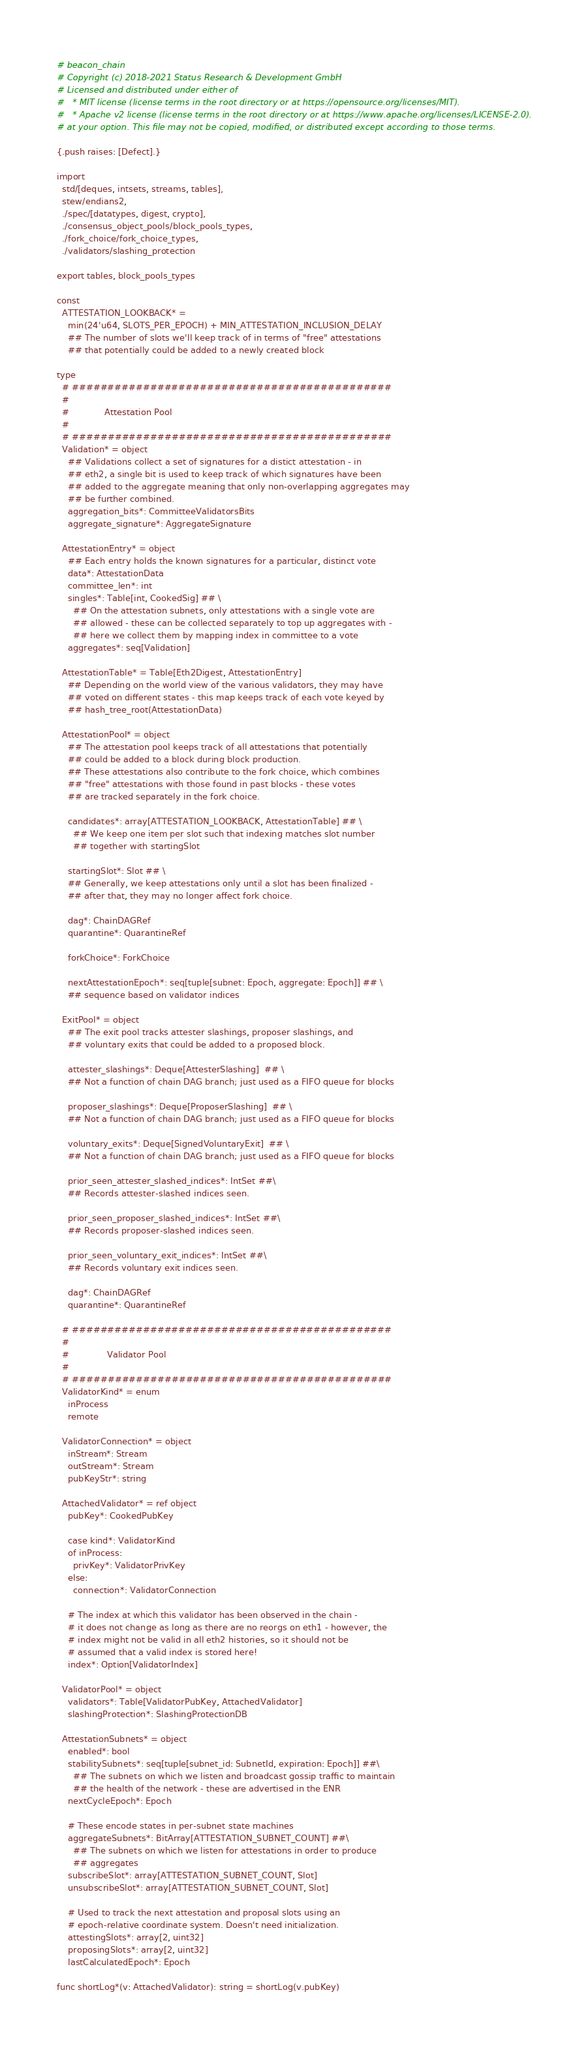Convert code to text. <code><loc_0><loc_0><loc_500><loc_500><_Nim_># beacon_chain
# Copyright (c) 2018-2021 Status Research & Development GmbH
# Licensed and distributed under either of
#   * MIT license (license terms in the root directory or at https://opensource.org/licenses/MIT).
#   * Apache v2 license (license terms in the root directory or at https://www.apache.org/licenses/LICENSE-2.0).
# at your option. This file may not be copied, modified, or distributed except according to those terms.

{.push raises: [Defect].}

import
  std/[deques, intsets, streams, tables],
  stew/endians2,
  ./spec/[datatypes, digest, crypto],
  ./consensus_object_pools/block_pools_types,
  ./fork_choice/fork_choice_types,
  ./validators/slashing_protection

export tables, block_pools_types

const
  ATTESTATION_LOOKBACK* =
    min(24'u64, SLOTS_PER_EPOCH) + MIN_ATTESTATION_INCLUSION_DELAY
    ## The number of slots we'll keep track of in terms of "free" attestations
    ## that potentially could be added to a newly created block

type
  # #############################################
  #
  #             Attestation Pool
  #
  # #############################################
  Validation* = object
    ## Validations collect a set of signatures for a distict attestation - in
    ## eth2, a single bit is used to keep track of which signatures have been
    ## added to the aggregate meaning that only non-overlapping aggregates may
    ## be further combined.
    aggregation_bits*: CommitteeValidatorsBits
    aggregate_signature*: AggregateSignature

  AttestationEntry* = object
    ## Each entry holds the known signatures for a particular, distinct vote
    data*: AttestationData
    committee_len*: int
    singles*: Table[int, CookedSig] ## \
      ## On the attestation subnets, only attestations with a single vote are
      ## allowed - these can be collected separately to top up aggregates with -
      ## here we collect them by mapping index in committee to a vote
    aggregates*: seq[Validation]

  AttestationTable* = Table[Eth2Digest, AttestationEntry]
    ## Depending on the world view of the various validators, they may have
    ## voted on different states - this map keeps track of each vote keyed by
    ## hash_tree_root(AttestationData)

  AttestationPool* = object
    ## The attestation pool keeps track of all attestations that potentially
    ## could be added to a block during block production.
    ## These attestations also contribute to the fork choice, which combines
    ## "free" attestations with those found in past blocks - these votes
    ## are tracked separately in the fork choice.

    candidates*: array[ATTESTATION_LOOKBACK, AttestationTable] ## \
      ## We keep one item per slot such that indexing matches slot number
      ## together with startingSlot

    startingSlot*: Slot ## \
    ## Generally, we keep attestations only until a slot has been finalized -
    ## after that, they may no longer affect fork choice.

    dag*: ChainDAGRef
    quarantine*: QuarantineRef

    forkChoice*: ForkChoice

    nextAttestationEpoch*: seq[tuple[subnet: Epoch, aggregate: Epoch]] ## \
    ## sequence based on validator indices

  ExitPool* = object
    ## The exit pool tracks attester slashings, proposer slashings, and
    ## voluntary exits that could be added to a proposed block.

    attester_slashings*: Deque[AttesterSlashing]  ## \
    ## Not a function of chain DAG branch; just used as a FIFO queue for blocks

    proposer_slashings*: Deque[ProposerSlashing]  ## \
    ## Not a function of chain DAG branch; just used as a FIFO queue for blocks

    voluntary_exits*: Deque[SignedVoluntaryExit]  ## \
    ## Not a function of chain DAG branch; just used as a FIFO queue for blocks

    prior_seen_attester_slashed_indices*: IntSet ##\
    ## Records attester-slashed indices seen.

    prior_seen_proposer_slashed_indices*: IntSet ##\
    ## Records proposer-slashed indices seen.

    prior_seen_voluntary_exit_indices*: IntSet ##\
    ## Records voluntary exit indices seen.

    dag*: ChainDAGRef
    quarantine*: QuarantineRef

  # #############################################
  #
  #              Validator Pool
  #
  # #############################################
  ValidatorKind* = enum
    inProcess
    remote

  ValidatorConnection* = object
    inStream*: Stream
    outStream*: Stream
    pubKeyStr*: string

  AttachedValidator* = ref object
    pubKey*: CookedPubKey

    case kind*: ValidatorKind
    of inProcess:
      privKey*: ValidatorPrivKey
    else:
      connection*: ValidatorConnection

    # The index at which this validator has been observed in the chain -
    # it does not change as long as there are no reorgs on eth1 - however, the
    # index might not be valid in all eth2 histories, so it should not be
    # assumed that a valid index is stored here!
    index*: Option[ValidatorIndex]

  ValidatorPool* = object
    validators*: Table[ValidatorPubKey, AttachedValidator]
    slashingProtection*: SlashingProtectionDB

  AttestationSubnets* = object
    enabled*: bool
    stabilitySubnets*: seq[tuple[subnet_id: SubnetId, expiration: Epoch]] ##\
      ## The subnets on which we listen and broadcast gossip traffic to maintain
      ## the health of the network - these are advertised in the ENR
    nextCycleEpoch*: Epoch

    # These encode states in per-subnet state machines
    aggregateSubnets*: BitArray[ATTESTATION_SUBNET_COUNT] ##\
      ## The subnets on which we listen for attestations in order to produce
      ## aggregates
    subscribeSlot*: array[ATTESTATION_SUBNET_COUNT, Slot]
    unsubscribeSlot*: array[ATTESTATION_SUBNET_COUNT, Slot]

    # Used to track the next attestation and proposal slots using an
    # epoch-relative coordinate system. Doesn't need initialization.
    attestingSlots*: array[2, uint32]
    proposingSlots*: array[2, uint32]
    lastCalculatedEpoch*: Epoch

func shortLog*(v: AttachedValidator): string = shortLog(v.pubKey)
</code> 